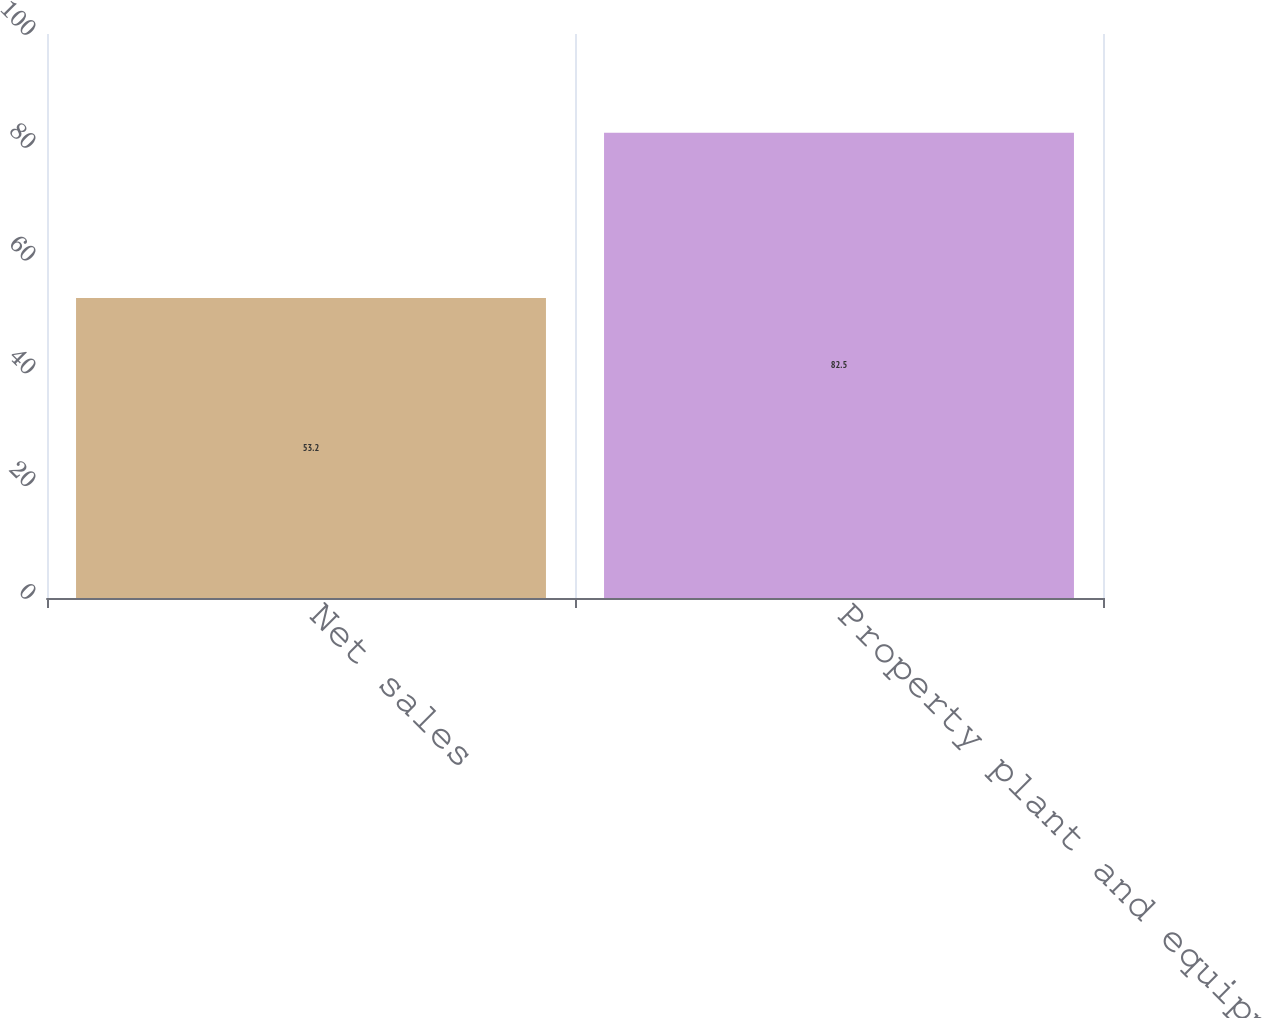<chart> <loc_0><loc_0><loc_500><loc_500><bar_chart><fcel>Net sales<fcel>Property plant and equipment<nl><fcel>53.2<fcel>82.5<nl></chart> 